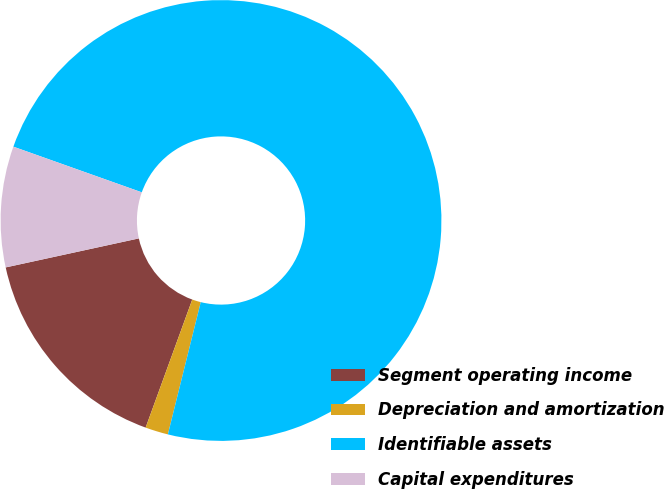Convert chart to OTSL. <chart><loc_0><loc_0><loc_500><loc_500><pie_chart><fcel>Segment operating income<fcel>Depreciation and amortization<fcel>Identifiable assets<fcel>Capital expenditures<nl><fcel>16.03%<fcel>1.68%<fcel>73.44%<fcel>8.85%<nl></chart> 